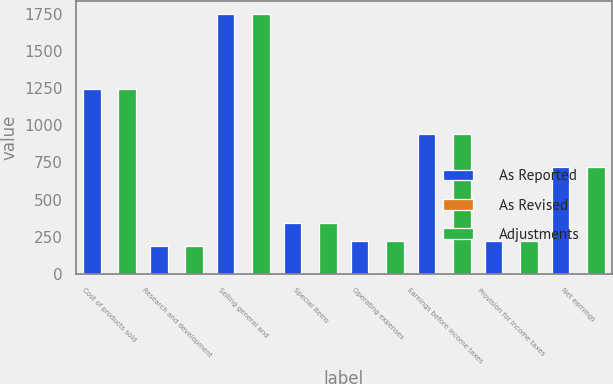Convert chart. <chart><loc_0><loc_0><loc_500><loc_500><stacked_bar_chart><ecel><fcel>Cost of products sold<fcel>Research and development<fcel>Selling general and<fcel>Special items<fcel>Operating expenses<fcel>Earnings before income taxes<fcel>Provision for income taxes<fcel>Net earnings<nl><fcel>As Reported<fcel>1242.7<fcel>187.9<fcel>1744.4<fcel>342.5<fcel>222.55<fcel>943.9<fcel>224.9<fcel>719<nl><fcel>As Revised<fcel>0.1<fcel>0.5<fcel>6.3<fcel>1.4<fcel>4.5<fcel>4.5<fcel>4.7<fcel>0.2<nl><fcel>Adjustments<fcel>1242.8<fcel>187.4<fcel>1750.7<fcel>341.1<fcel>222.55<fcel>939.4<fcel>220.2<fcel>719.2<nl></chart> 